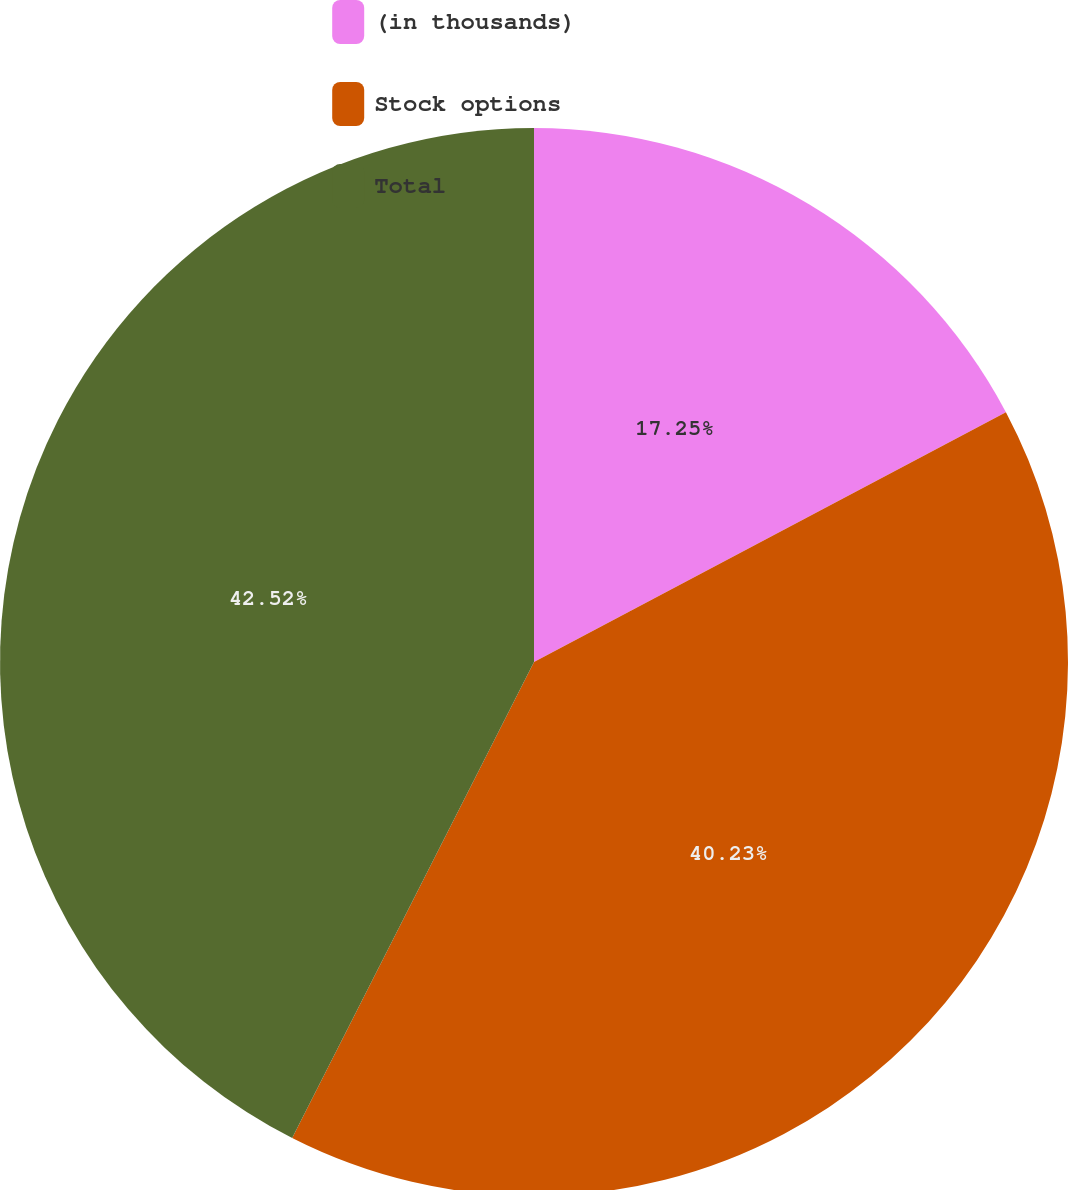Convert chart. <chart><loc_0><loc_0><loc_500><loc_500><pie_chart><fcel>(in thousands)<fcel>Stock options<fcel>Total<nl><fcel>17.25%<fcel>40.23%<fcel>42.52%<nl></chart> 